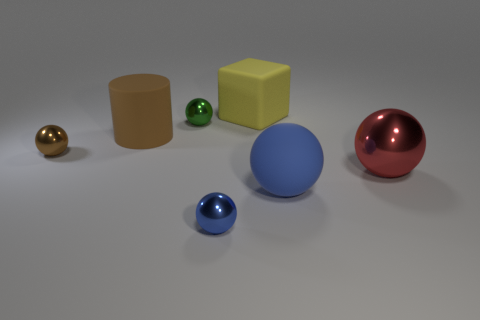What can we say about the lighting and shadows in this scene? The lighting in the scene seems to be coming from the upper right, judging by the shadows cast to the lower left of the objects. The shadows are soft-edged, suggesting a diffused light source, and each object casts a shadow that's consistent with its shape. 